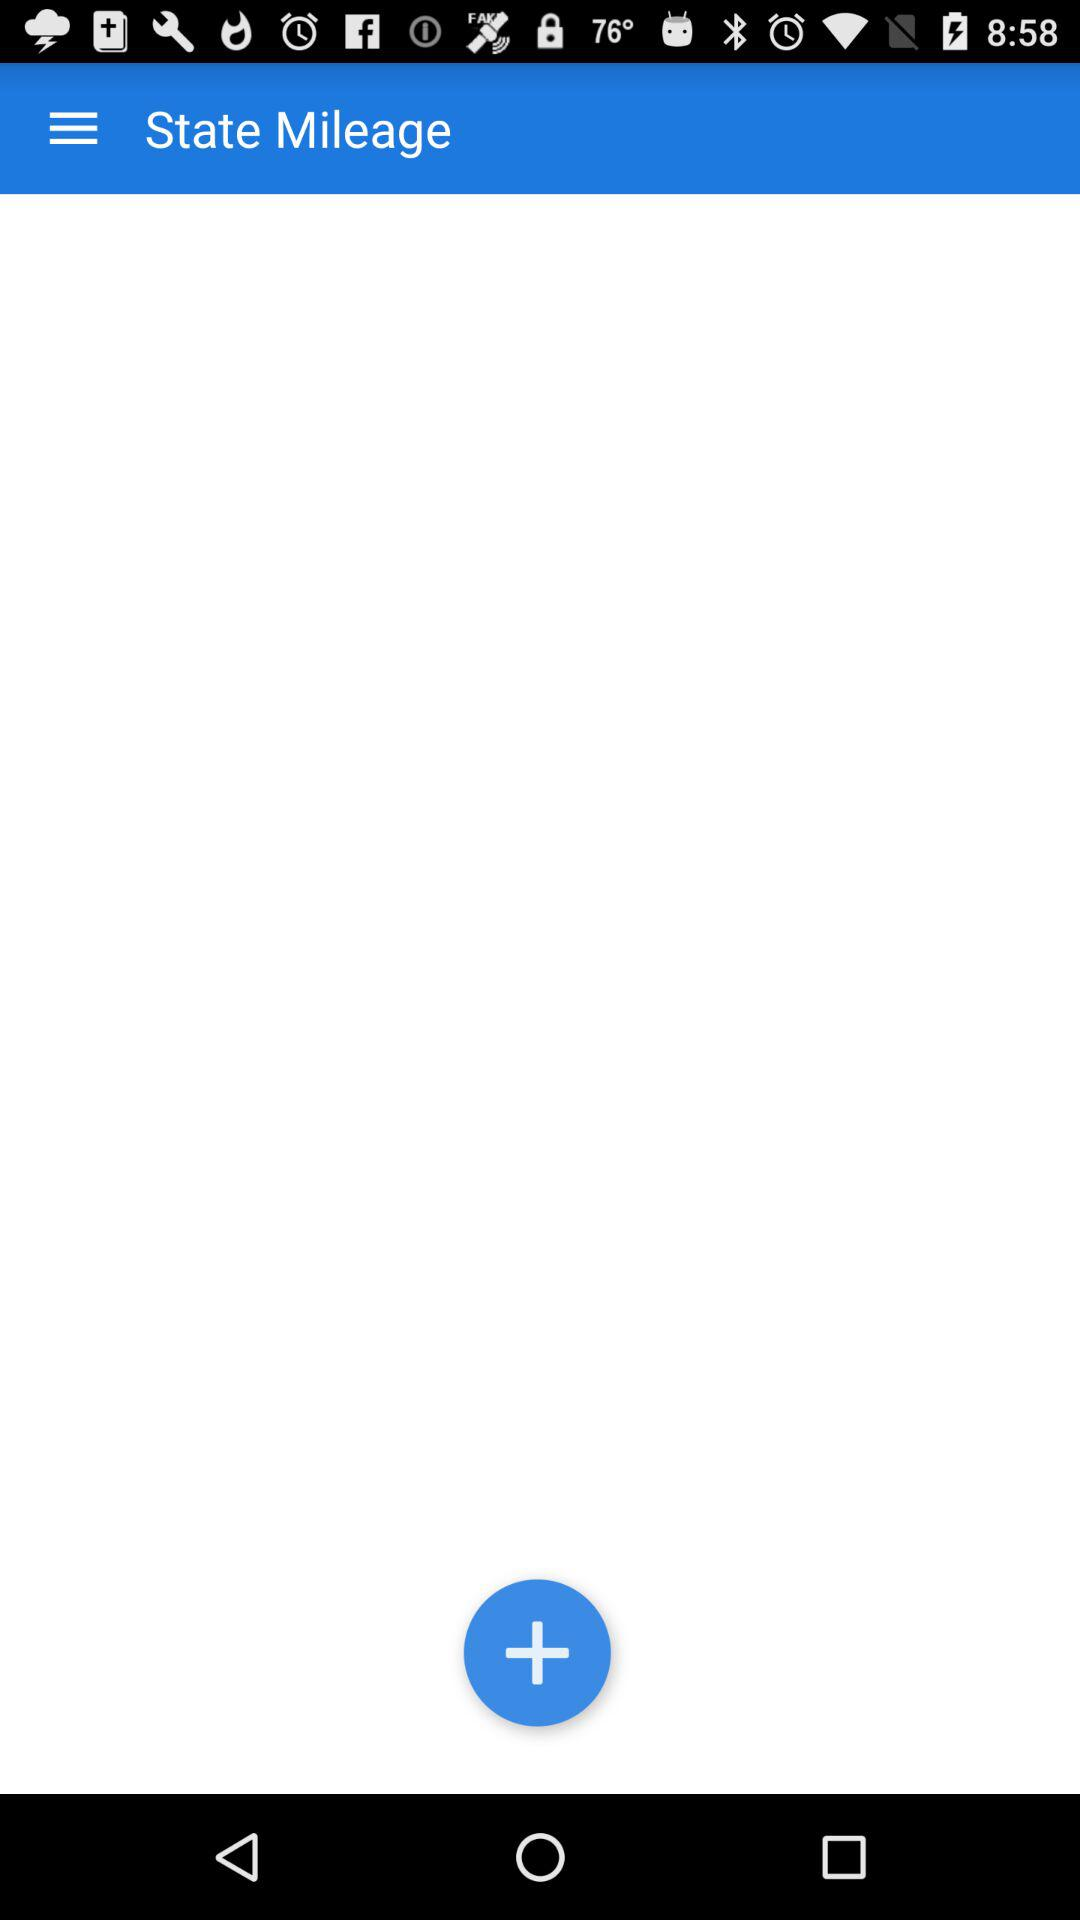What is the application name?
When the provided information is insufficient, respond with <no answer>. <no answer> 